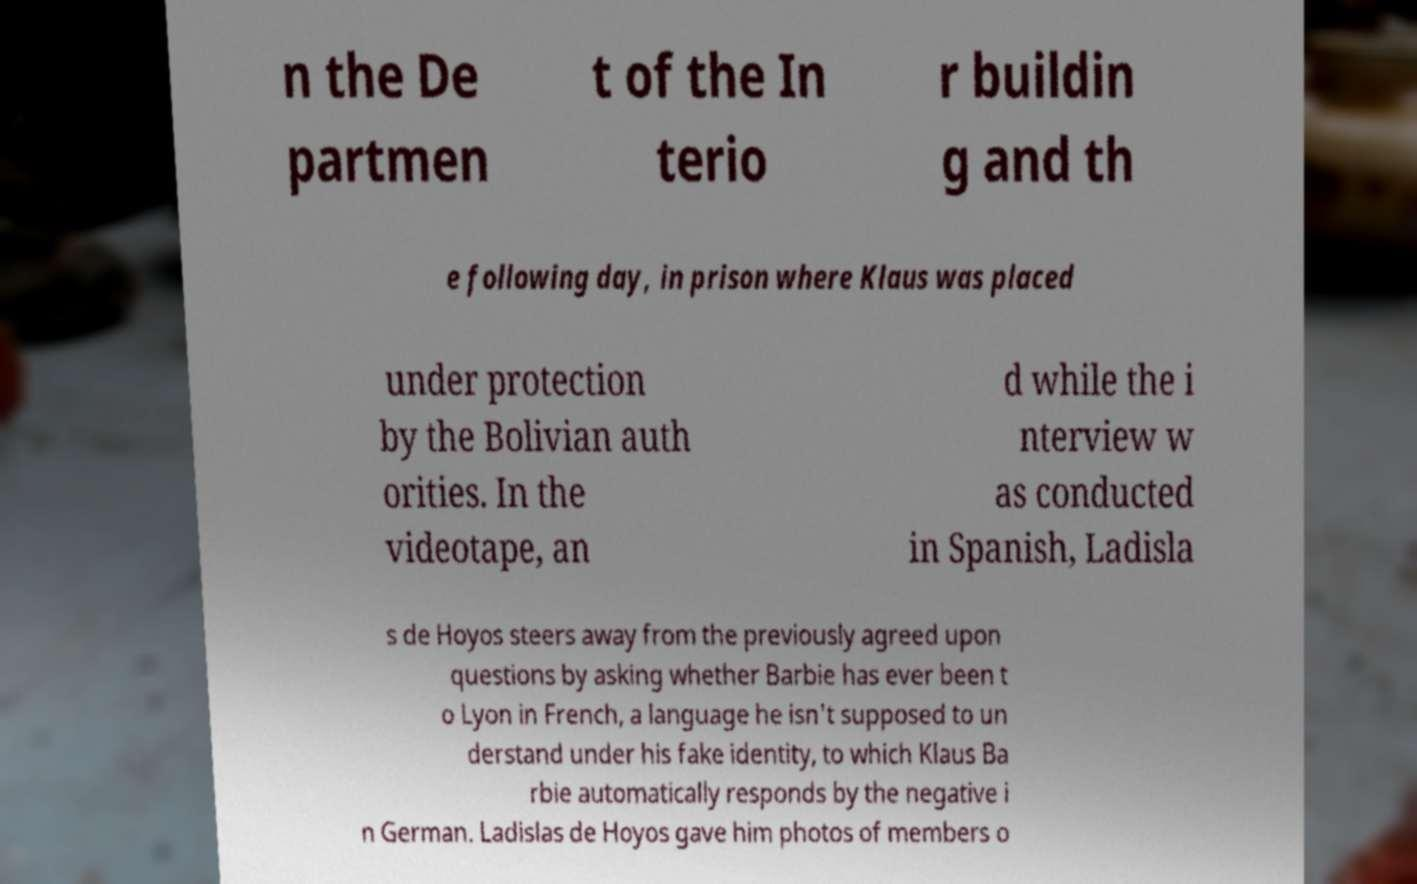Can you read and provide the text displayed in the image?This photo seems to have some interesting text. Can you extract and type it out for me? n the De partmen t of the In terio r buildin g and th e following day, in prison where Klaus was placed under protection by the Bolivian auth orities. In the videotape, an d while the i nterview w as conducted in Spanish, Ladisla s de Hoyos steers away from the previously agreed upon questions by asking whether Barbie has ever been t o Lyon in French, a language he isn't supposed to un derstand under his fake identity, to which Klaus Ba rbie automatically responds by the negative i n German. Ladislas de Hoyos gave him photos of members o 